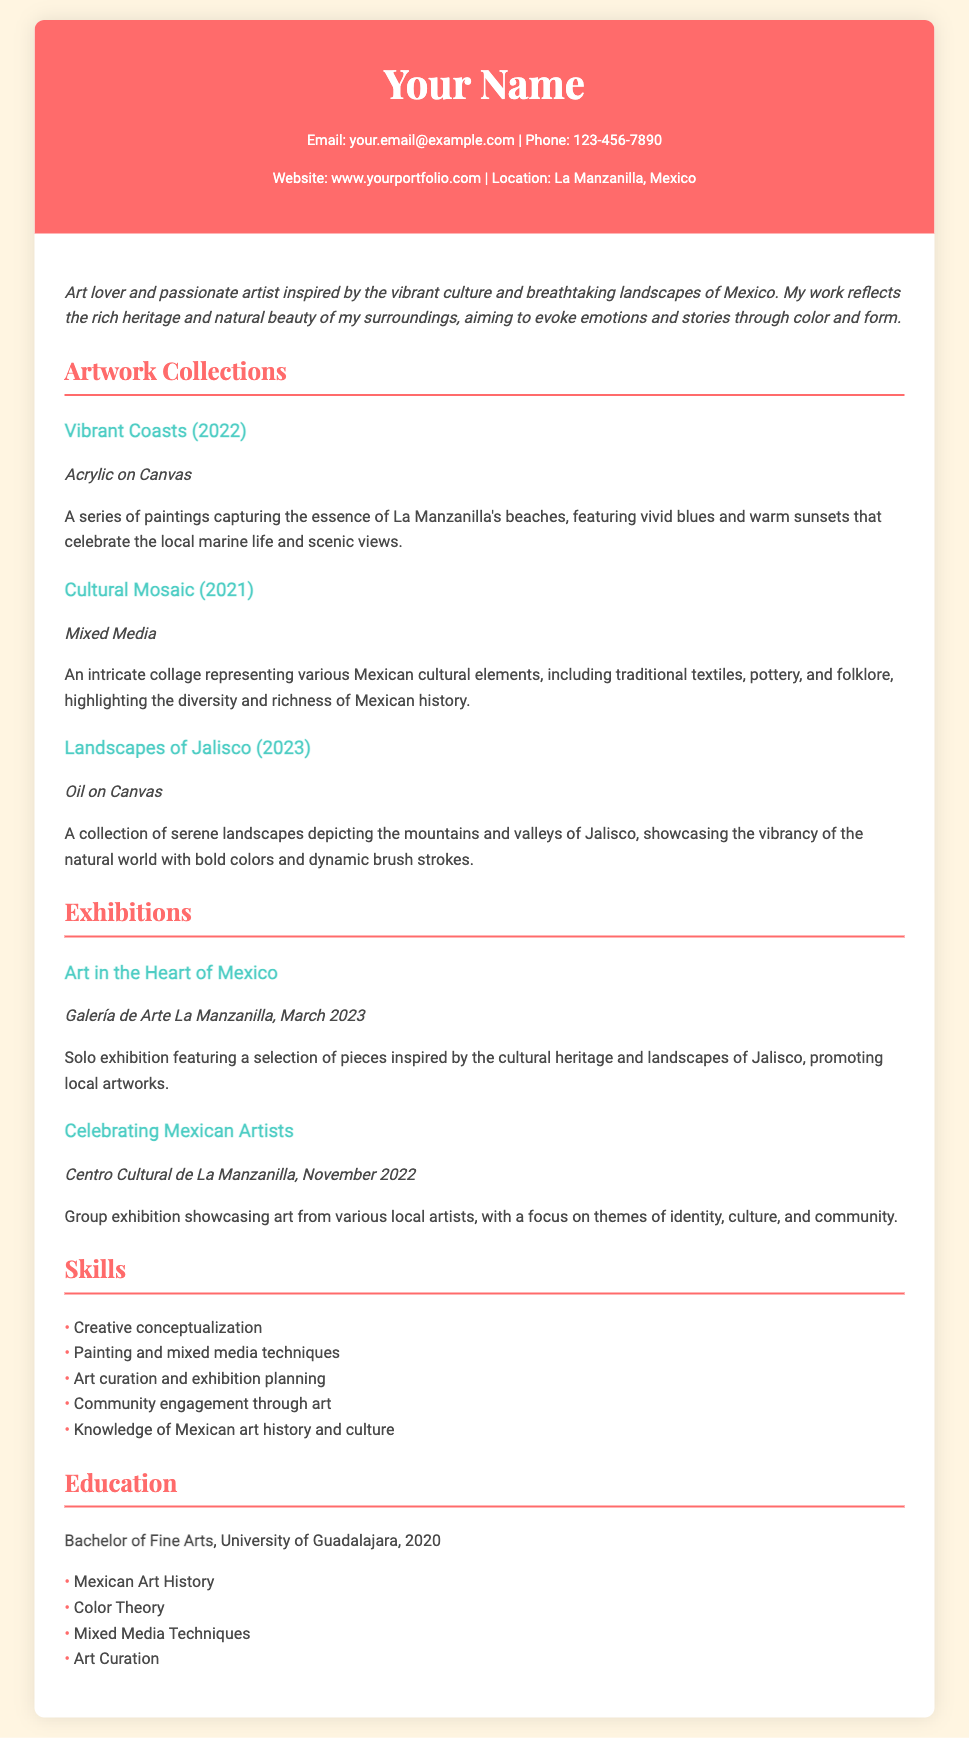what is the name of the solo exhibition? The solo exhibition is titled "Art in the Heart of Mexico" as stated in the exhibitions section.
Answer: Art in the Heart of Mexico what year was the "Cultural Mosaic" collection created? The "Cultural Mosaic" collection was created in 2021, as indicated in the artwork collections section.
Answer: 2021 how many skills are listed in the Skills section? There are five skills listed in the Skills section, which can be counted directly from the document.
Answer: 5 what type of medium is used in "Landscapes of Jalisco"? The "Landscapes of Jalisco" collection is created using Oil on Canvas, as mentioned in the artwork descriptions.
Answer: Oil on Canvas which location hosted the "Celebrating Mexican Artists" exhibition? The "Celebrating Mexican Artists" exhibition was held at the Centro Cultural de La Manzanilla, as stated in the exhibitions section.
Answer: Centro Cultural de La Manzanilla what is the name of the artist? The artist's name can be found in the header but is placeholder text "Your Name".
Answer: Your Name what degree was earned at the University of Guadalajara? The document indicates that a Bachelor of Fine Arts was earned at the University of Guadalajara.
Answer: Bachelor of Fine Arts what is a key theme represented in "Vibrant Coasts"? The key theme in "Vibrant Coasts" is capturing the essence of La Manzanilla's beaches, as described in the artwork collection.
Answer: La Manzanilla's beaches 